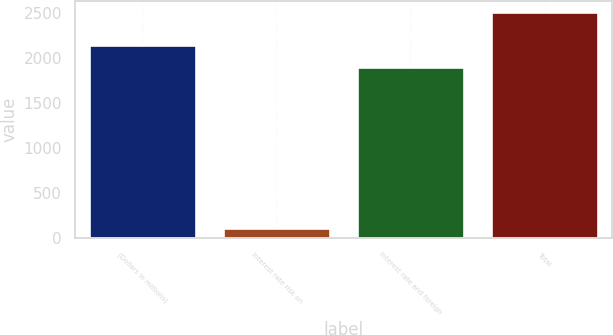Convert chart. <chart><loc_0><loc_0><loc_500><loc_500><bar_chart><fcel>(Dollars in millions)<fcel>Interest rate risk on<fcel>Interest rate and foreign<fcel>Total<nl><fcel>2138.6<fcel>105<fcel>1898<fcel>2511<nl></chart> 